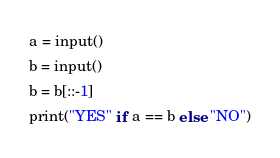<code> <loc_0><loc_0><loc_500><loc_500><_Python_>a = input()
b = input()
b = b[::-1]
print("YES" if a == b else "NO")</code> 